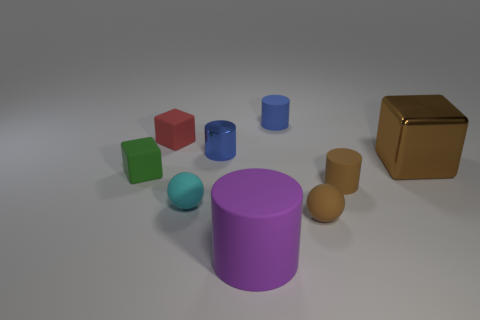Subtract all large brown cubes. How many cubes are left? 2 Subtract all gray blocks. How many blue cylinders are left? 2 Subtract 1 cubes. How many cubes are left? 2 Subtract all purple cylinders. How many cylinders are left? 3 Add 1 brown cylinders. How many objects exist? 10 Subtract all purple blocks. Subtract all blue spheres. How many blocks are left? 3 Subtract all spheres. How many objects are left? 7 Subtract 1 cyan balls. How many objects are left? 8 Subtract all cyan matte spheres. Subtract all blue metal things. How many objects are left? 7 Add 1 tiny red objects. How many tiny red objects are left? 2 